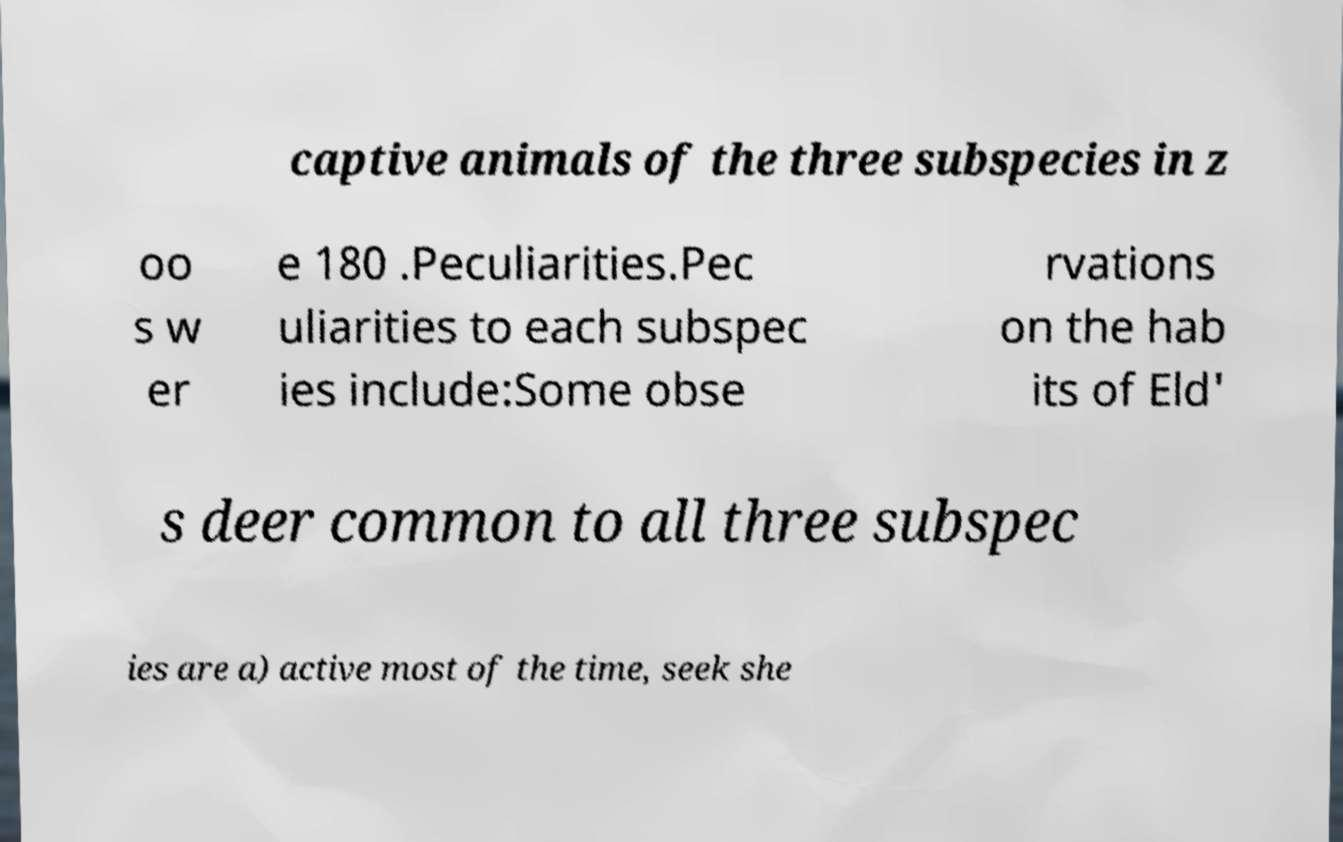Please identify and transcribe the text found in this image. captive animals of the three subspecies in z oo s w er e 180 .Peculiarities.Pec uliarities to each subspec ies include:Some obse rvations on the hab its of Eld' s deer common to all three subspec ies are a) active most of the time, seek she 